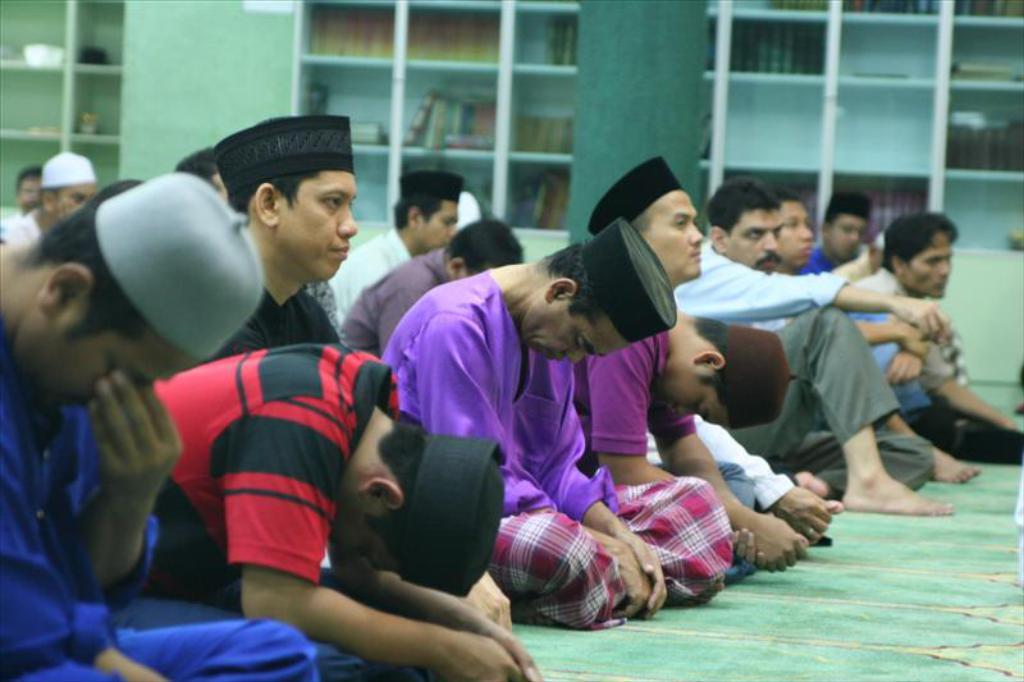What are the people in the image wearing on their heads? There are people wearing caps in the image. How are the people in the image positioned? There is a group of people sitting on the floor in the image. What can be seen in the background of the image? There are books on shelves and walls visible in the background of the image. What type of sand can be seen in the image? There is no sand present in the image. 